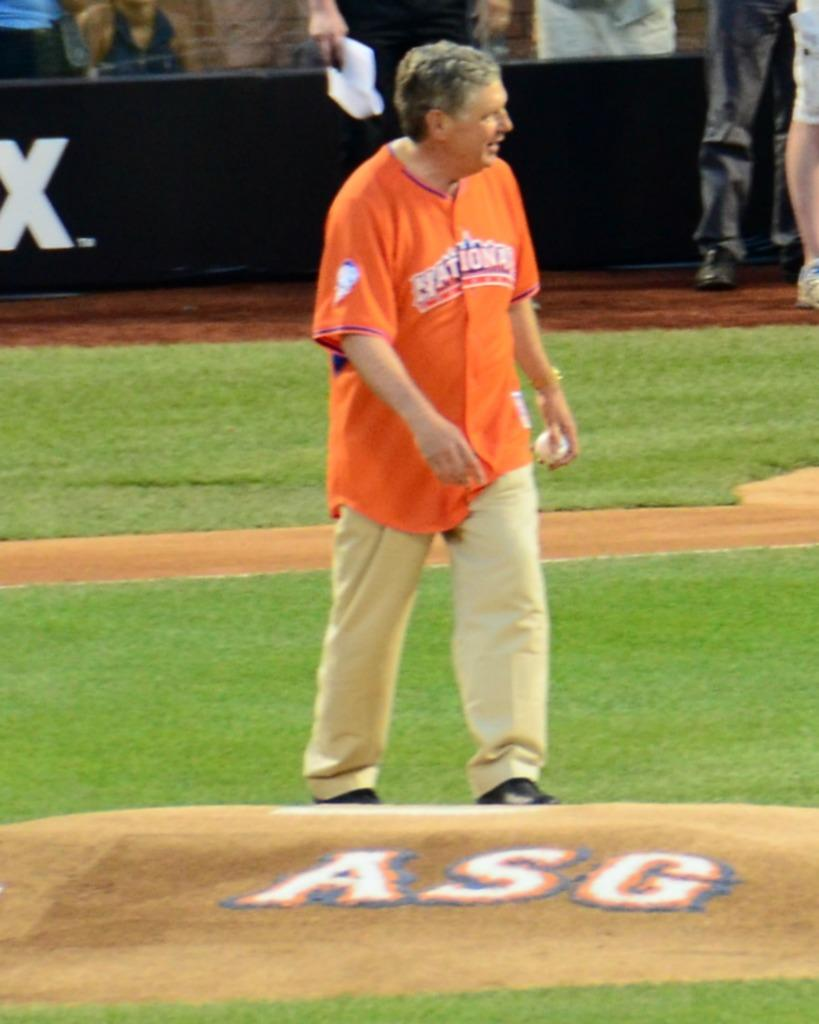<image>
Summarize the visual content of the image. A man in an orange Nationals jersey walks out to the ASG pitching mound. 